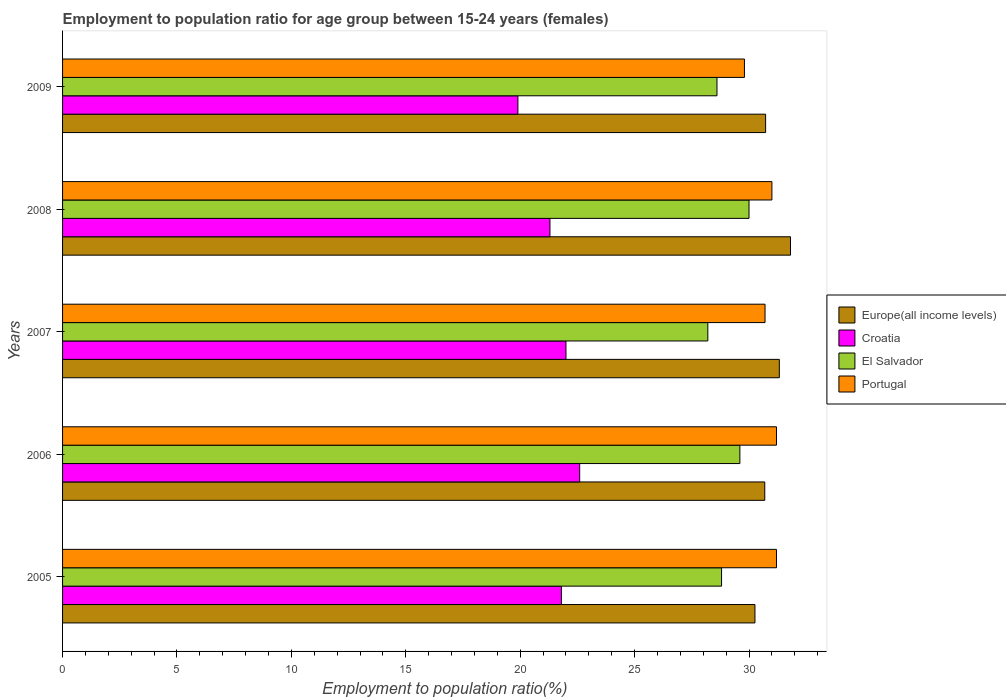How many different coloured bars are there?
Provide a succinct answer. 4. How many groups of bars are there?
Give a very brief answer. 5. Are the number of bars on each tick of the Y-axis equal?
Your answer should be compact. Yes. In how many cases, is the number of bars for a given year not equal to the number of legend labels?
Give a very brief answer. 0. What is the employment to population ratio in Croatia in 2008?
Provide a succinct answer. 21.3. Across all years, what is the maximum employment to population ratio in Portugal?
Make the answer very short. 31.2. Across all years, what is the minimum employment to population ratio in El Salvador?
Offer a very short reply. 28.2. What is the total employment to population ratio in El Salvador in the graph?
Provide a succinct answer. 145.2. What is the difference between the employment to population ratio in Europe(all income levels) in 2006 and that in 2009?
Ensure brevity in your answer.  -0.04. What is the difference between the employment to population ratio in Europe(all income levels) in 2005 and the employment to population ratio in Portugal in 2008?
Offer a terse response. -0.74. What is the average employment to population ratio in Europe(all income levels) per year?
Make the answer very short. 30.96. In the year 2009, what is the difference between the employment to population ratio in Portugal and employment to population ratio in El Salvador?
Offer a terse response. 1.2. In how many years, is the employment to population ratio in El Salvador greater than 2 %?
Give a very brief answer. 5. What is the ratio of the employment to population ratio in Portugal in 2007 to that in 2008?
Make the answer very short. 0.99. Is the employment to population ratio in Croatia in 2006 less than that in 2009?
Your answer should be very brief. No. Is the difference between the employment to population ratio in Portugal in 2005 and 2009 greater than the difference between the employment to population ratio in El Salvador in 2005 and 2009?
Your response must be concise. Yes. What is the difference between the highest and the second highest employment to population ratio in Portugal?
Your response must be concise. 0. What is the difference between the highest and the lowest employment to population ratio in Portugal?
Make the answer very short. 1.4. What does the 3rd bar from the top in 2009 represents?
Your response must be concise. Croatia. Is it the case that in every year, the sum of the employment to population ratio in Portugal and employment to population ratio in El Salvador is greater than the employment to population ratio in Europe(all income levels)?
Provide a succinct answer. Yes. Are all the bars in the graph horizontal?
Offer a very short reply. Yes. How many years are there in the graph?
Ensure brevity in your answer.  5. What is the difference between two consecutive major ticks on the X-axis?
Give a very brief answer. 5. Are the values on the major ticks of X-axis written in scientific E-notation?
Offer a very short reply. No. Does the graph contain any zero values?
Provide a succinct answer. No. Does the graph contain grids?
Make the answer very short. No. What is the title of the graph?
Offer a very short reply. Employment to population ratio for age group between 15-24 years (females). Does "Pacific island small states" appear as one of the legend labels in the graph?
Provide a succinct answer. No. What is the label or title of the Y-axis?
Provide a short and direct response. Years. What is the Employment to population ratio(%) in Europe(all income levels) in 2005?
Your response must be concise. 30.26. What is the Employment to population ratio(%) of Croatia in 2005?
Offer a terse response. 21.8. What is the Employment to population ratio(%) in El Salvador in 2005?
Your answer should be very brief. 28.8. What is the Employment to population ratio(%) of Portugal in 2005?
Make the answer very short. 31.2. What is the Employment to population ratio(%) in Europe(all income levels) in 2006?
Offer a very short reply. 30.69. What is the Employment to population ratio(%) of Croatia in 2006?
Provide a short and direct response. 22.6. What is the Employment to population ratio(%) of El Salvador in 2006?
Make the answer very short. 29.6. What is the Employment to population ratio(%) of Portugal in 2006?
Your answer should be very brief. 31.2. What is the Employment to population ratio(%) in Europe(all income levels) in 2007?
Provide a succinct answer. 31.32. What is the Employment to population ratio(%) in El Salvador in 2007?
Your answer should be compact. 28.2. What is the Employment to population ratio(%) of Portugal in 2007?
Your response must be concise. 30.7. What is the Employment to population ratio(%) of Europe(all income levels) in 2008?
Give a very brief answer. 31.81. What is the Employment to population ratio(%) in Croatia in 2008?
Provide a short and direct response. 21.3. What is the Employment to population ratio(%) of Europe(all income levels) in 2009?
Provide a succinct answer. 30.73. What is the Employment to population ratio(%) in Croatia in 2009?
Offer a very short reply. 19.9. What is the Employment to population ratio(%) in El Salvador in 2009?
Ensure brevity in your answer.  28.6. What is the Employment to population ratio(%) in Portugal in 2009?
Give a very brief answer. 29.8. Across all years, what is the maximum Employment to population ratio(%) of Europe(all income levels)?
Offer a terse response. 31.81. Across all years, what is the maximum Employment to population ratio(%) in Croatia?
Ensure brevity in your answer.  22.6. Across all years, what is the maximum Employment to population ratio(%) of El Salvador?
Make the answer very short. 30. Across all years, what is the maximum Employment to population ratio(%) in Portugal?
Provide a short and direct response. 31.2. Across all years, what is the minimum Employment to population ratio(%) in Europe(all income levels)?
Provide a succinct answer. 30.26. Across all years, what is the minimum Employment to population ratio(%) in Croatia?
Provide a short and direct response. 19.9. Across all years, what is the minimum Employment to population ratio(%) in El Salvador?
Your answer should be compact. 28.2. Across all years, what is the minimum Employment to population ratio(%) in Portugal?
Keep it short and to the point. 29.8. What is the total Employment to population ratio(%) of Europe(all income levels) in the graph?
Keep it short and to the point. 154.81. What is the total Employment to population ratio(%) of Croatia in the graph?
Your response must be concise. 107.6. What is the total Employment to population ratio(%) in El Salvador in the graph?
Offer a terse response. 145.2. What is the total Employment to population ratio(%) of Portugal in the graph?
Keep it short and to the point. 153.9. What is the difference between the Employment to population ratio(%) in Europe(all income levels) in 2005 and that in 2006?
Provide a succinct answer. -0.43. What is the difference between the Employment to population ratio(%) in El Salvador in 2005 and that in 2006?
Offer a terse response. -0.8. What is the difference between the Employment to population ratio(%) of Portugal in 2005 and that in 2006?
Offer a terse response. 0. What is the difference between the Employment to population ratio(%) in Europe(all income levels) in 2005 and that in 2007?
Your answer should be compact. -1.07. What is the difference between the Employment to population ratio(%) of Europe(all income levels) in 2005 and that in 2008?
Provide a short and direct response. -1.55. What is the difference between the Employment to population ratio(%) in El Salvador in 2005 and that in 2008?
Your answer should be compact. -1.2. What is the difference between the Employment to population ratio(%) of Europe(all income levels) in 2005 and that in 2009?
Your answer should be compact. -0.47. What is the difference between the Employment to population ratio(%) of Croatia in 2005 and that in 2009?
Keep it short and to the point. 1.9. What is the difference between the Employment to population ratio(%) of El Salvador in 2005 and that in 2009?
Provide a short and direct response. 0.2. What is the difference between the Employment to population ratio(%) of Portugal in 2005 and that in 2009?
Make the answer very short. 1.4. What is the difference between the Employment to population ratio(%) of Europe(all income levels) in 2006 and that in 2007?
Provide a short and direct response. -0.64. What is the difference between the Employment to population ratio(%) in Croatia in 2006 and that in 2007?
Offer a very short reply. 0.6. What is the difference between the Employment to population ratio(%) in Portugal in 2006 and that in 2007?
Keep it short and to the point. 0.5. What is the difference between the Employment to population ratio(%) of Europe(all income levels) in 2006 and that in 2008?
Give a very brief answer. -1.12. What is the difference between the Employment to population ratio(%) of Portugal in 2006 and that in 2008?
Your answer should be compact. 0.2. What is the difference between the Employment to population ratio(%) of Europe(all income levels) in 2006 and that in 2009?
Provide a succinct answer. -0.04. What is the difference between the Employment to population ratio(%) in El Salvador in 2006 and that in 2009?
Offer a very short reply. 1. What is the difference between the Employment to population ratio(%) of Europe(all income levels) in 2007 and that in 2008?
Provide a short and direct response. -0.49. What is the difference between the Employment to population ratio(%) of Portugal in 2007 and that in 2008?
Your answer should be very brief. -0.3. What is the difference between the Employment to population ratio(%) of Europe(all income levels) in 2007 and that in 2009?
Your answer should be very brief. 0.6. What is the difference between the Employment to population ratio(%) of Portugal in 2007 and that in 2009?
Ensure brevity in your answer.  0.9. What is the difference between the Employment to population ratio(%) in Europe(all income levels) in 2008 and that in 2009?
Provide a short and direct response. 1.09. What is the difference between the Employment to population ratio(%) in Europe(all income levels) in 2005 and the Employment to population ratio(%) in Croatia in 2006?
Your answer should be compact. 7.66. What is the difference between the Employment to population ratio(%) of Europe(all income levels) in 2005 and the Employment to population ratio(%) of El Salvador in 2006?
Keep it short and to the point. 0.66. What is the difference between the Employment to population ratio(%) in Europe(all income levels) in 2005 and the Employment to population ratio(%) in Portugal in 2006?
Offer a terse response. -0.94. What is the difference between the Employment to population ratio(%) of El Salvador in 2005 and the Employment to population ratio(%) of Portugal in 2006?
Keep it short and to the point. -2.4. What is the difference between the Employment to population ratio(%) of Europe(all income levels) in 2005 and the Employment to population ratio(%) of Croatia in 2007?
Your answer should be very brief. 8.26. What is the difference between the Employment to population ratio(%) of Europe(all income levels) in 2005 and the Employment to population ratio(%) of El Salvador in 2007?
Your answer should be very brief. 2.06. What is the difference between the Employment to population ratio(%) in Europe(all income levels) in 2005 and the Employment to population ratio(%) in Portugal in 2007?
Your response must be concise. -0.44. What is the difference between the Employment to population ratio(%) in Croatia in 2005 and the Employment to population ratio(%) in El Salvador in 2007?
Make the answer very short. -6.4. What is the difference between the Employment to population ratio(%) of Croatia in 2005 and the Employment to population ratio(%) of Portugal in 2007?
Your answer should be compact. -8.9. What is the difference between the Employment to population ratio(%) of Europe(all income levels) in 2005 and the Employment to population ratio(%) of Croatia in 2008?
Your answer should be compact. 8.96. What is the difference between the Employment to population ratio(%) in Europe(all income levels) in 2005 and the Employment to population ratio(%) in El Salvador in 2008?
Give a very brief answer. 0.26. What is the difference between the Employment to population ratio(%) in Europe(all income levels) in 2005 and the Employment to population ratio(%) in Portugal in 2008?
Provide a succinct answer. -0.74. What is the difference between the Employment to population ratio(%) in Croatia in 2005 and the Employment to population ratio(%) in El Salvador in 2008?
Ensure brevity in your answer.  -8.2. What is the difference between the Employment to population ratio(%) of Croatia in 2005 and the Employment to population ratio(%) of Portugal in 2008?
Offer a terse response. -9.2. What is the difference between the Employment to population ratio(%) of El Salvador in 2005 and the Employment to population ratio(%) of Portugal in 2008?
Provide a succinct answer. -2.2. What is the difference between the Employment to population ratio(%) of Europe(all income levels) in 2005 and the Employment to population ratio(%) of Croatia in 2009?
Ensure brevity in your answer.  10.36. What is the difference between the Employment to population ratio(%) in Europe(all income levels) in 2005 and the Employment to population ratio(%) in El Salvador in 2009?
Make the answer very short. 1.66. What is the difference between the Employment to population ratio(%) in Europe(all income levels) in 2005 and the Employment to population ratio(%) in Portugal in 2009?
Provide a short and direct response. 0.46. What is the difference between the Employment to population ratio(%) in Croatia in 2005 and the Employment to population ratio(%) in Portugal in 2009?
Provide a short and direct response. -8. What is the difference between the Employment to population ratio(%) of El Salvador in 2005 and the Employment to population ratio(%) of Portugal in 2009?
Make the answer very short. -1. What is the difference between the Employment to population ratio(%) in Europe(all income levels) in 2006 and the Employment to population ratio(%) in Croatia in 2007?
Your answer should be very brief. 8.69. What is the difference between the Employment to population ratio(%) in Europe(all income levels) in 2006 and the Employment to population ratio(%) in El Salvador in 2007?
Your response must be concise. 2.49. What is the difference between the Employment to population ratio(%) of Europe(all income levels) in 2006 and the Employment to population ratio(%) of Portugal in 2007?
Keep it short and to the point. -0.01. What is the difference between the Employment to population ratio(%) of Croatia in 2006 and the Employment to population ratio(%) of El Salvador in 2007?
Provide a succinct answer. -5.6. What is the difference between the Employment to population ratio(%) of Croatia in 2006 and the Employment to population ratio(%) of Portugal in 2007?
Keep it short and to the point. -8.1. What is the difference between the Employment to population ratio(%) in El Salvador in 2006 and the Employment to population ratio(%) in Portugal in 2007?
Ensure brevity in your answer.  -1.1. What is the difference between the Employment to population ratio(%) in Europe(all income levels) in 2006 and the Employment to population ratio(%) in Croatia in 2008?
Provide a short and direct response. 9.39. What is the difference between the Employment to population ratio(%) in Europe(all income levels) in 2006 and the Employment to population ratio(%) in El Salvador in 2008?
Make the answer very short. 0.69. What is the difference between the Employment to population ratio(%) of Europe(all income levels) in 2006 and the Employment to population ratio(%) of Portugal in 2008?
Provide a succinct answer. -0.31. What is the difference between the Employment to population ratio(%) in Croatia in 2006 and the Employment to population ratio(%) in El Salvador in 2008?
Your answer should be very brief. -7.4. What is the difference between the Employment to population ratio(%) in Europe(all income levels) in 2006 and the Employment to population ratio(%) in Croatia in 2009?
Make the answer very short. 10.79. What is the difference between the Employment to population ratio(%) of Europe(all income levels) in 2006 and the Employment to population ratio(%) of El Salvador in 2009?
Ensure brevity in your answer.  2.09. What is the difference between the Employment to population ratio(%) in Europe(all income levels) in 2006 and the Employment to population ratio(%) in Portugal in 2009?
Make the answer very short. 0.89. What is the difference between the Employment to population ratio(%) in Croatia in 2006 and the Employment to population ratio(%) in El Salvador in 2009?
Offer a terse response. -6. What is the difference between the Employment to population ratio(%) in El Salvador in 2006 and the Employment to population ratio(%) in Portugal in 2009?
Ensure brevity in your answer.  -0.2. What is the difference between the Employment to population ratio(%) in Europe(all income levels) in 2007 and the Employment to population ratio(%) in Croatia in 2008?
Provide a succinct answer. 10.02. What is the difference between the Employment to population ratio(%) in Europe(all income levels) in 2007 and the Employment to population ratio(%) in El Salvador in 2008?
Give a very brief answer. 1.32. What is the difference between the Employment to population ratio(%) in Europe(all income levels) in 2007 and the Employment to population ratio(%) in Portugal in 2008?
Keep it short and to the point. 0.32. What is the difference between the Employment to population ratio(%) in Croatia in 2007 and the Employment to population ratio(%) in Portugal in 2008?
Ensure brevity in your answer.  -9. What is the difference between the Employment to population ratio(%) in Europe(all income levels) in 2007 and the Employment to population ratio(%) in Croatia in 2009?
Your answer should be very brief. 11.42. What is the difference between the Employment to population ratio(%) of Europe(all income levels) in 2007 and the Employment to population ratio(%) of El Salvador in 2009?
Make the answer very short. 2.72. What is the difference between the Employment to population ratio(%) in Europe(all income levels) in 2007 and the Employment to population ratio(%) in Portugal in 2009?
Provide a succinct answer. 1.52. What is the difference between the Employment to population ratio(%) of Croatia in 2007 and the Employment to population ratio(%) of El Salvador in 2009?
Provide a succinct answer. -6.6. What is the difference between the Employment to population ratio(%) in Croatia in 2007 and the Employment to population ratio(%) in Portugal in 2009?
Give a very brief answer. -7.8. What is the difference between the Employment to population ratio(%) of Europe(all income levels) in 2008 and the Employment to population ratio(%) of Croatia in 2009?
Offer a terse response. 11.91. What is the difference between the Employment to population ratio(%) in Europe(all income levels) in 2008 and the Employment to population ratio(%) in El Salvador in 2009?
Your answer should be very brief. 3.21. What is the difference between the Employment to population ratio(%) in Europe(all income levels) in 2008 and the Employment to population ratio(%) in Portugal in 2009?
Provide a short and direct response. 2.01. What is the difference between the Employment to population ratio(%) of Croatia in 2008 and the Employment to population ratio(%) of El Salvador in 2009?
Your answer should be compact. -7.3. What is the average Employment to population ratio(%) in Europe(all income levels) per year?
Keep it short and to the point. 30.96. What is the average Employment to population ratio(%) of Croatia per year?
Offer a very short reply. 21.52. What is the average Employment to population ratio(%) in El Salvador per year?
Ensure brevity in your answer.  29.04. What is the average Employment to population ratio(%) in Portugal per year?
Your response must be concise. 30.78. In the year 2005, what is the difference between the Employment to population ratio(%) in Europe(all income levels) and Employment to population ratio(%) in Croatia?
Provide a succinct answer. 8.46. In the year 2005, what is the difference between the Employment to population ratio(%) of Europe(all income levels) and Employment to population ratio(%) of El Salvador?
Make the answer very short. 1.46. In the year 2005, what is the difference between the Employment to population ratio(%) of Europe(all income levels) and Employment to population ratio(%) of Portugal?
Your response must be concise. -0.94. In the year 2005, what is the difference between the Employment to population ratio(%) in El Salvador and Employment to population ratio(%) in Portugal?
Give a very brief answer. -2.4. In the year 2006, what is the difference between the Employment to population ratio(%) of Europe(all income levels) and Employment to population ratio(%) of Croatia?
Offer a terse response. 8.09. In the year 2006, what is the difference between the Employment to population ratio(%) in Europe(all income levels) and Employment to population ratio(%) in El Salvador?
Your response must be concise. 1.09. In the year 2006, what is the difference between the Employment to population ratio(%) of Europe(all income levels) and Employment to population ratio(%) of Portugal?
Offer a very short reply. -0.51. In the year 2006, what is the difference between the Employment to population ratio(%) in Croatia and Employment to population ratio(%) in El Salvador?
Offer a terse response. -7. In the year 2006, what is the difference between the Employment to population ratio(%) of El Salvador and Employment to population ratio(%) of Portugal?
Keep it short and to the point. -1.6. In the year 2007, what is the difference between the Employment to population ratio(%) of Europe(all income levels) and Employment to population ratio(%) of Croatia?
Offer a very short reply. 9.32. In the year 2007, what is the difference between the Employment to population ratio(%) in Europe(all income levels) and Employment to population ratio(%) in El Salvador?
Your answer should be compact. 3.12. In the year 2007, what is the difference between the Employment to population ratio(%) of Europe(all income levels) and Employment to population ratio(%) of Portugal?
Keep it short and to the point. 0.62. In the year 2007, what is the difference between the Employment to population ratio(%) in El Salvador and Employment to population ratio(%) in Portugal?
Keep it short and to the point. -2.5. In the year 2008, what is the difference between the Employment to population ratio(%) in Europe(all income levels) and Employment to population ratio(%) in Croatia?
Provide a succinct answer. 10.51. In the year 2008, what is the difference between the Employment to population ratio(%) in Europe(all income levels) and Employment to population ratio(%) in El Salvador?
Provide a short and direct response. 1.81. In the year 2008, what is the difference between the Employment to population ratio(%) of Europe(all income levels) and Employment to population ratio(%) of Portugal?
Provide a succinct answer. 0.81. In the year 2008, what is the difference between the Employment to population ratio(%) in Croatia and Employment to population ratio(%) in El Salvador?
Provide a short and direct response. -8.7. In the year 2008, what is the difference between the Employment to population ratio(%) of El Salvador and Employment to population ratio(%) of Portugal?
Offer a terse response. -1. In the year 2009, what is the difference between the Employment to population ratio(%) of Europe(all income levels) and Employment to population ratio(%) of Croatia?
Your answer should be compact. 10.83. In the year 2009, what is the difference between the Employment to population ratio(%) in Europe(all income levels) and Employment to population ratio(%) in El Salvador?
Provide a succinct answer. 2.13. In the year 2009, what is the difference between the Employment to population ratio(%) in Europe(all income levels) and Employment to population ratio(%) in Portugal?
Make the answer very short. 0.93. In the year 2009, what is the difference between the Employment to population ratio(%) of Croatia and Employment to population ratio(%) of El Salvador?
Your answer should be compact. -8.7. In the year 2009, what is the difference between the Employment to population ratio(%) of El Salvador and Employment to population ratio(%) of Portugal?
Your response must be concise. -1.2. What is the ratio of the Employment to population ratio(%) in Croatia in 2005 to that in 2006?
Your response must be concise. 0.96. What is the ratio of the Employment to population ratio(%) in Portugal in 2005 to that in 2006?
Your answer should be compact. 1. What is the ratio of the Employment to population ratio(%) in Croatia in 2005 to that in 2007?
Offer a very short reply. 0.99. What is the ratio of the Employment to population ratio(%) of El Salvador in 2005 to that in 2007?
Provide a short and direct response. 1.02. What is the ratio of the Employment to population ratio(%) of Portugal in 2005 to that in 2007?
Make the answer very short. 1.02. What is the ratio of the Employment to population ratio(%) in Europe(all income levels) in 2005 to that in 2008?
Give a very brief answer. 0.95. What is the ratio of the Employment to population ratio(%) of Croatia in 2005 to that in 2008?
Your answer should be very brief. 1.02. What is the ratio of the Employment to population ratio(%) of El Salvador in 2005 to that in 2008?
Your answer should be compact. 0.96. What is the ratio of the Employment to population ratio(%) in Europe(all income levels) in 2005 to that in 2009?
Keep it short and to the point. 0.98. What is the ratio of the Employment to population ratio(%) in Croatia in 2005 to that in 2009?
Give a very brief answer. 1.1. What is the ratio of the Employment to population ratio(%) of El Salvador in 2005 to that in 2009?
Provide a short and direct response. 1.01. What is the ratio of the Employment to population ratio(%) of Portugal in 2005 to that in 2009?
Provide a short and direct response. 1.05. What is the ratio of the Employment to population ratio(%) in Europe(all income levels) in 2006 to that in 2007?
Your answer should be compact. 0.98. What is the ratio of the Employment to population ratio(%) of Croatia in 2006 to that in 2007?
Provide a succinct answer. 1.03. What is the ratio of the Employment to population ratio(%) of El Salvador in 2006 to that in 2007?
Offer a terse response. 1.05. What is the ratio of the Employment to population ratio(%) of Portugal in 2006 to that in 2007?
Make the answer very short. 1.02. What is the ratio of the Employment to population ratio(%) of Europe(all income levels) in 2006 to that in 2008?
Give a very brief answer. 0.96. What is the ratio of the Employment to population ratio(%) in Croatia in 2006 to that in 2008?
Keep it short and to the point. 1.06. What is the ratio of the Employment to population ratio(%) of El Salvador in 2006 to that in 2008?
Provide a succinct answer. 0.99. What is the ratio of the Employment to population ratio(%) in Portugal in 2006 to that in 2008?
Your answer should be very brief. 1.01. What is the ratio of the Employment to population ratio(%) in Croatia in 2006 to that in 2009?
Keep it short and to the point. 1.14. What is the ratio of the Employment to population ratio(%) in El Salvador in 2006 to that in 2009?
Give a very brief answer. 1.03. What is the ratio of the Employment to population ratio(%) of Portugal in 2006 to that in 2009?
Your response must be concise. 1.05. What is the ratio of the Employment to population ratio(%) in Europe(all income levels) in 2007 to that in 2008?
Offer a very short reply. 0.98. What is the ratio of the Employment to population ratio(%) of Croatia in 2007 to that in 2008?
Provide a succinct answer. 1.03. What is the ratio of the Employment to population ratio(%) in Portugal in 2007 to that in 2008?
Your answer should be very brief. 0.99. What is the ratio of the Employment to population ratio(%) of Europe(all income levels) in 2007 to that in 2009?
Give a very brief answer. 1.02. What is the ratio of the Employment to population ratio(%) in Croatia in 2007 to that in 2009?
Give a very brief answer. 1.11. What is the ratio of the Employment to population ratio(%) of Portugal in 2007 to that in 2009?
Provide a short and direct response. 1.03. What is the ratio of the Employment to population ratio(%) of Europe(all income levels) in 2008 to that in 2009?
Your answer should be very brief. 1.04. What is the ratio of the Employment to population ratio(%) in Croatia in 2008 to that in 2009?
Give a very brief answer. 1.07. What is the ratio of the Employment to population ratio(%) of El Salvador in 2008 to that in 2009?
Offer a very short reply. 1.05. What is the ratio of the Employment to population ratio(%) of Portugal in 2008 to that in 2009?
Your answer should be compact. 1.04. What is the difference between the highest and the second highest Employment to population ratio(%) in Europe(all income levels)?
Ensure brevity in your answer.  0.49. What is the difference between the highest and the second highest Employment to population ratio(%) in El Salvador?
Provide a succinct answer. 0.4. What is the difference between the highest and the second highest Employment to population ratio(%) of Portugal?
Give a very brief answer. 0. What is the difference between the highest and the lowest Employment to population ratio(%) of Europe(all income levels)?
Your answer should be compact. 1.55. What is the difference between the highest and the lowest Employment to population ratio(%) in Portugal?
Your response must be concise. 1.4. 